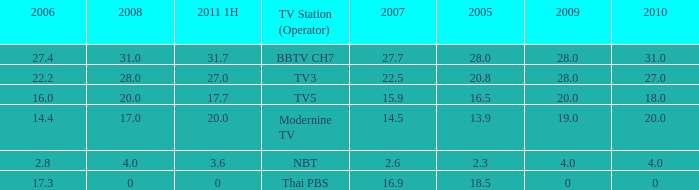What is the highest 2011 1H value for a 2005 over 28? None. 